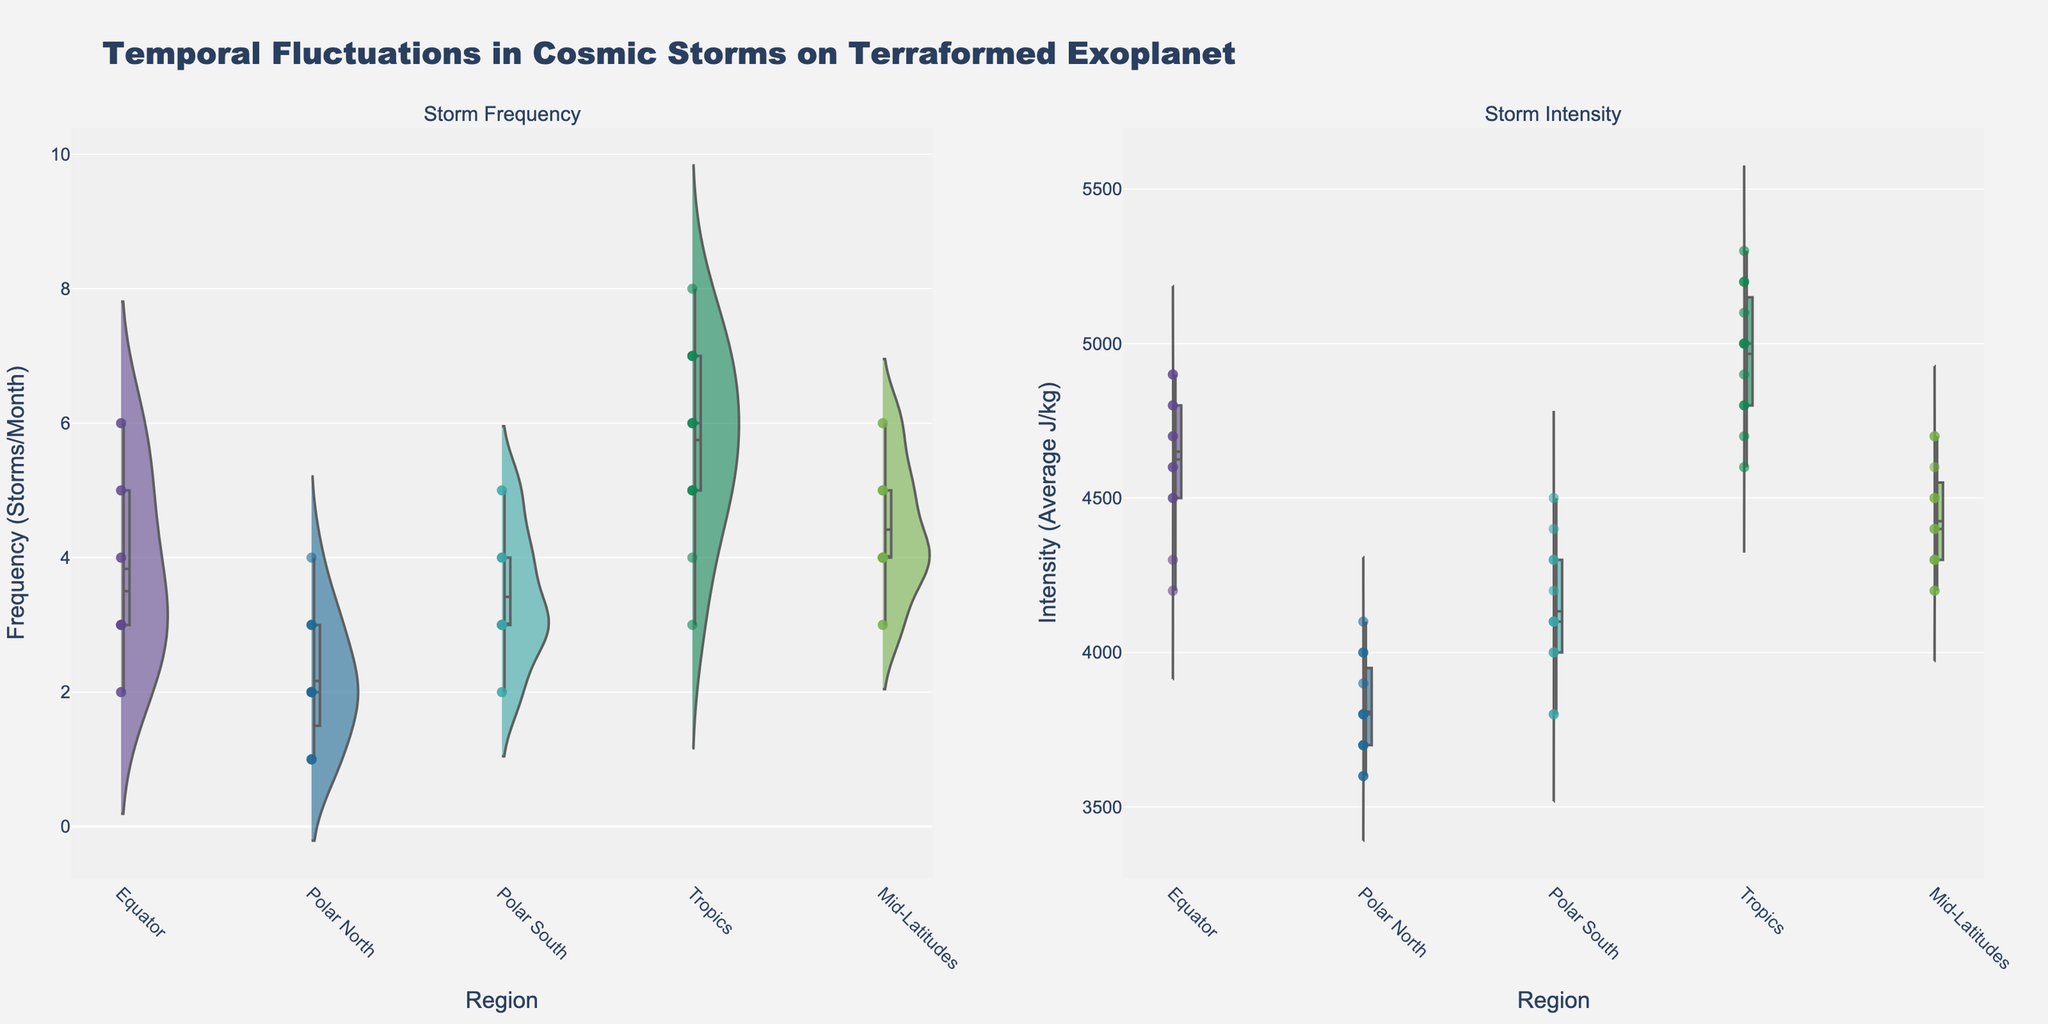How many geographic regions are compared in the figure? By observing the number of unique categories on the x-axis, we can count the distinct geographic regions compared. They are Equator, Polar North, Polar South, Tropics, and Mid-Latitudes.
Answer: 5 Which region exhibits the highest average storm intensity? In the subplot dedicated to storm intensity, each region's violin plot and scatter points can provide visual cues about the central tendency. The Tropics region, with its markers at higher average values, shows the highest intensity.
Answer: Tropics Evaluate the median storm frequency in the Equator region and compare it to that in the Polar North. The violin plot for the frequency of storms shows distinct median lines for each region. By comparing these, it’s evident that the Equator has a higher median frequency than Polar North.
Answer: Equator > Polar North What is the primary insight about the distribution of storm frequencies and intensities in the Tropics? The Tropics display a wide and high-distribution in both frequency and intensity in their respective violin plots, suggesting more frequent and energetically severe storms compared to other regions. This is reinforced by densely packed scatter points higher up on the y-axis.
Answer: High frequency and intensity How do storm frequencies in Mid-Latitudes compare to those at the Equator? Observing the height and spread of the violin plots for frequency, it’s clear that the Mid-Latitudes have a similar but slightly broader distribution in terms of storm frequency compared to the Equator.
Answer: Similar, slightly broader distribution in Mid-Latitudes Identify the region with the least variation in storm intensity. In the intensity subplot, the Polar North region shows the smallest spread in its violin plot, indicating the least variation in storm intensity.
Answer: Polar North What is the average intensity of storms in the Mid-Latitudes during May and November? By looking at the scatter points for storm intensity in May and November for the Mid-Latitudes region, we find they are around 4500 J/kg. The average can be approximated as (4500 + 4400) / 2 = 4450 J/kg.
Answer: 4450 J/kg Which region shows the most clustered storm frequency data points? Examining the distribution and overlap of scatter points, the Equator region shows a densely packed cluster, indicating frequent similar storm occurrences.
Answer: Equator Compare the storm intensity trends between Polar South and Mid-Latitudes. From the violin plots and scatter points in the intensity subplot, we see that Polar South has consistently higher average storm intensities compared to Mid-Latitudes, with broader spread towards higher values.
Answer: Polar South has higher intensities 